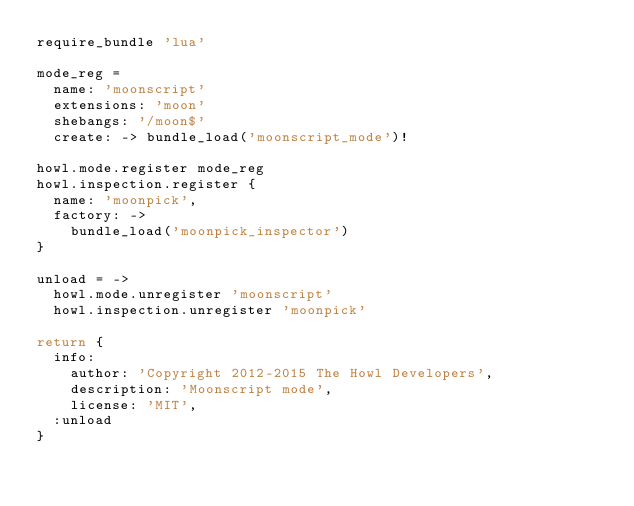Convert code to text. <code><loc_0><loc_0><loc_500><loc_500><_MoonScript_>require_bundle 'lua'

mode_reg =
  name: 'moonscript'
  extensions: 'moon'
  shebangs: '/moon$'
  create: -> bundle_load('moonscript_mode')!

howl.mode.register mode_reg
howl.inspection.register {
  name: 'moonpick',
  factory: ->
    bundle_load('moonpick_inspector')
}

unload = ->
  howl.mode.unregister 'moonscript'
  howl.inspection.unregister 'moonpick'

return {
  info:
    author: 'Copyright 2012-2015 The Howl Developers',
    description: 'Moonscript mode',
    license: 'MIT',
  :unload
}
</code> 